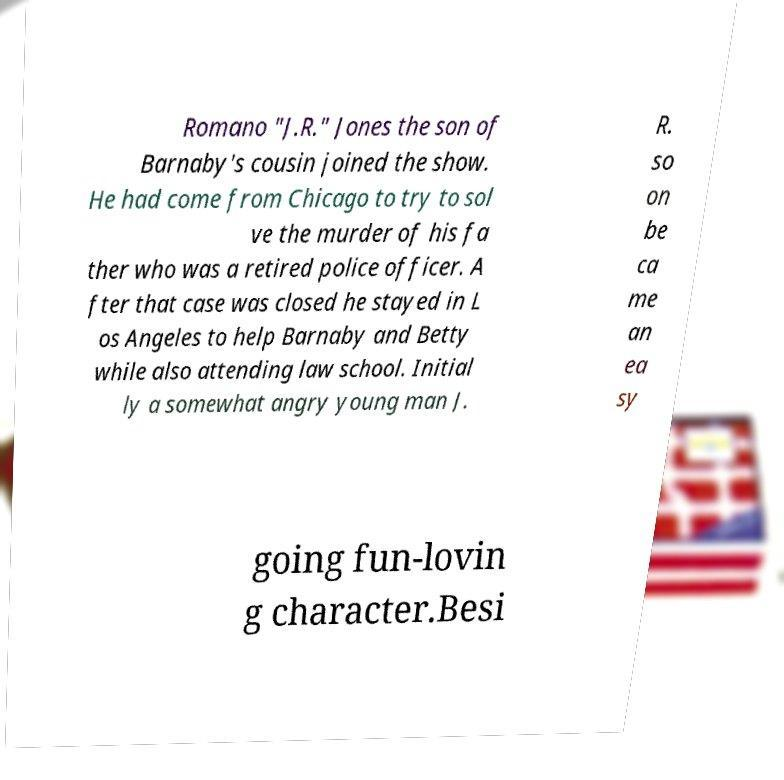Please identify and transcribe the text found in this image. Romano "J.R." Jones the son of Barnaby's cousin joined the show. He had come from Chicago to try to sol ve the murder of his fa ther who was a retired police officer. A fter that case was closed he stayed in L os Angeles to help Barnaby and Betty while also attending law school. Initial ly a somewhat angry young man J. R. so on be ca me an ea sy going fun-lovin g character.Besi 